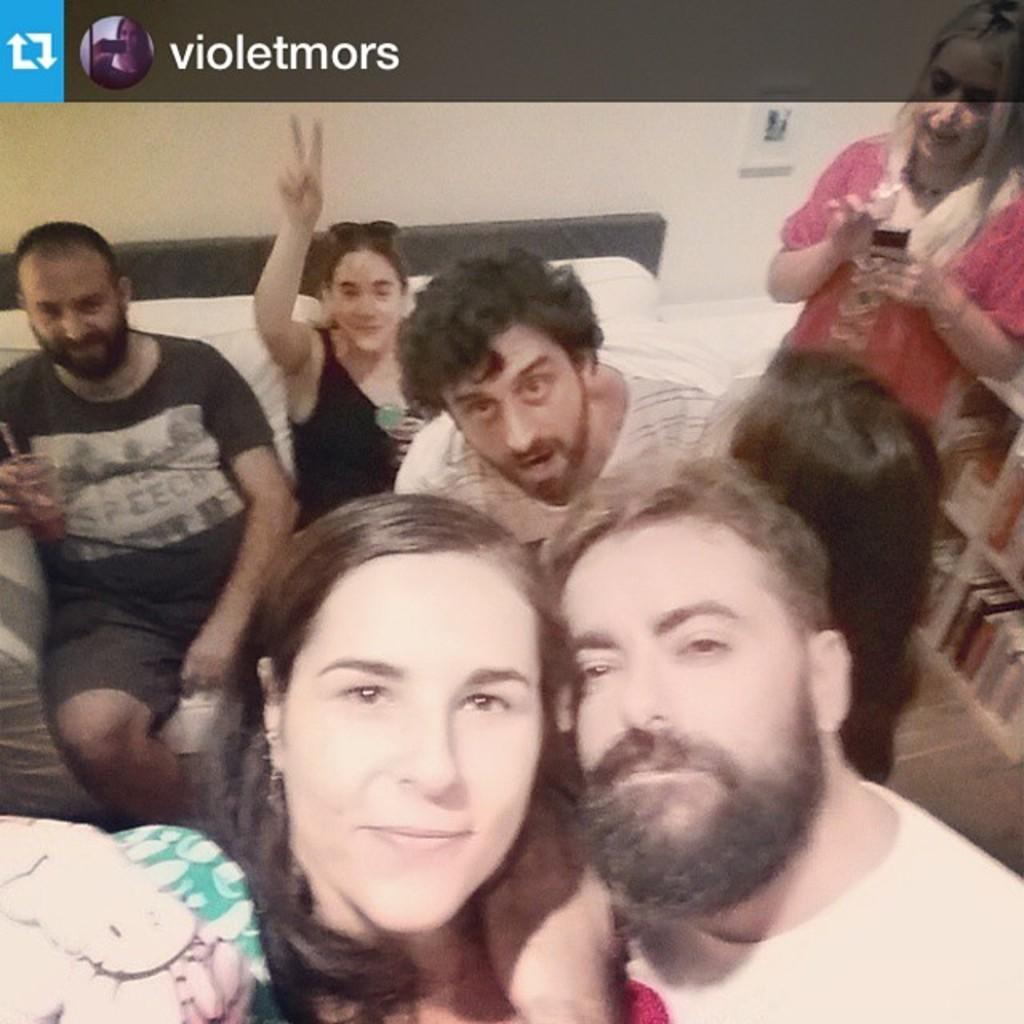In one or two sentences, can you explain what this image depicts? This image consists of few persons. At the bottom, there is a sofa. In the background, there is a wall. 